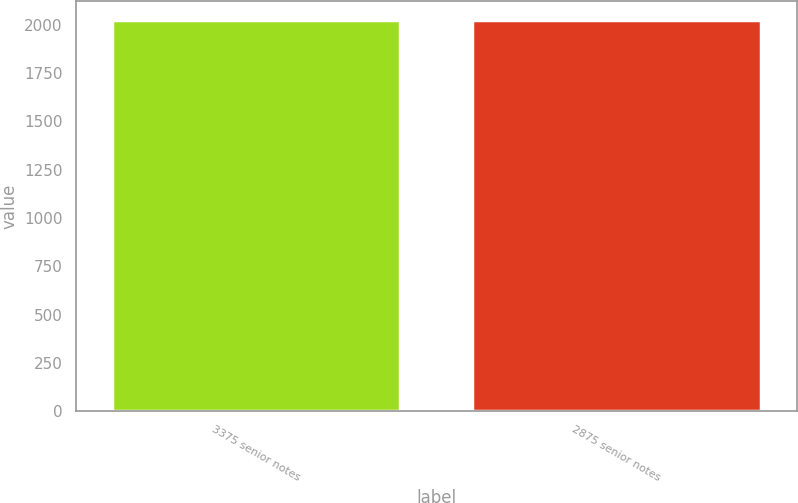Convert chart. <chart><loc_0><loc_0><loc_500><loc_500><bar_chart><fcel>3375 senior notes<fcel>2875 senior notes<nl><fcel>2023<fcel>2024<nl></chart> 